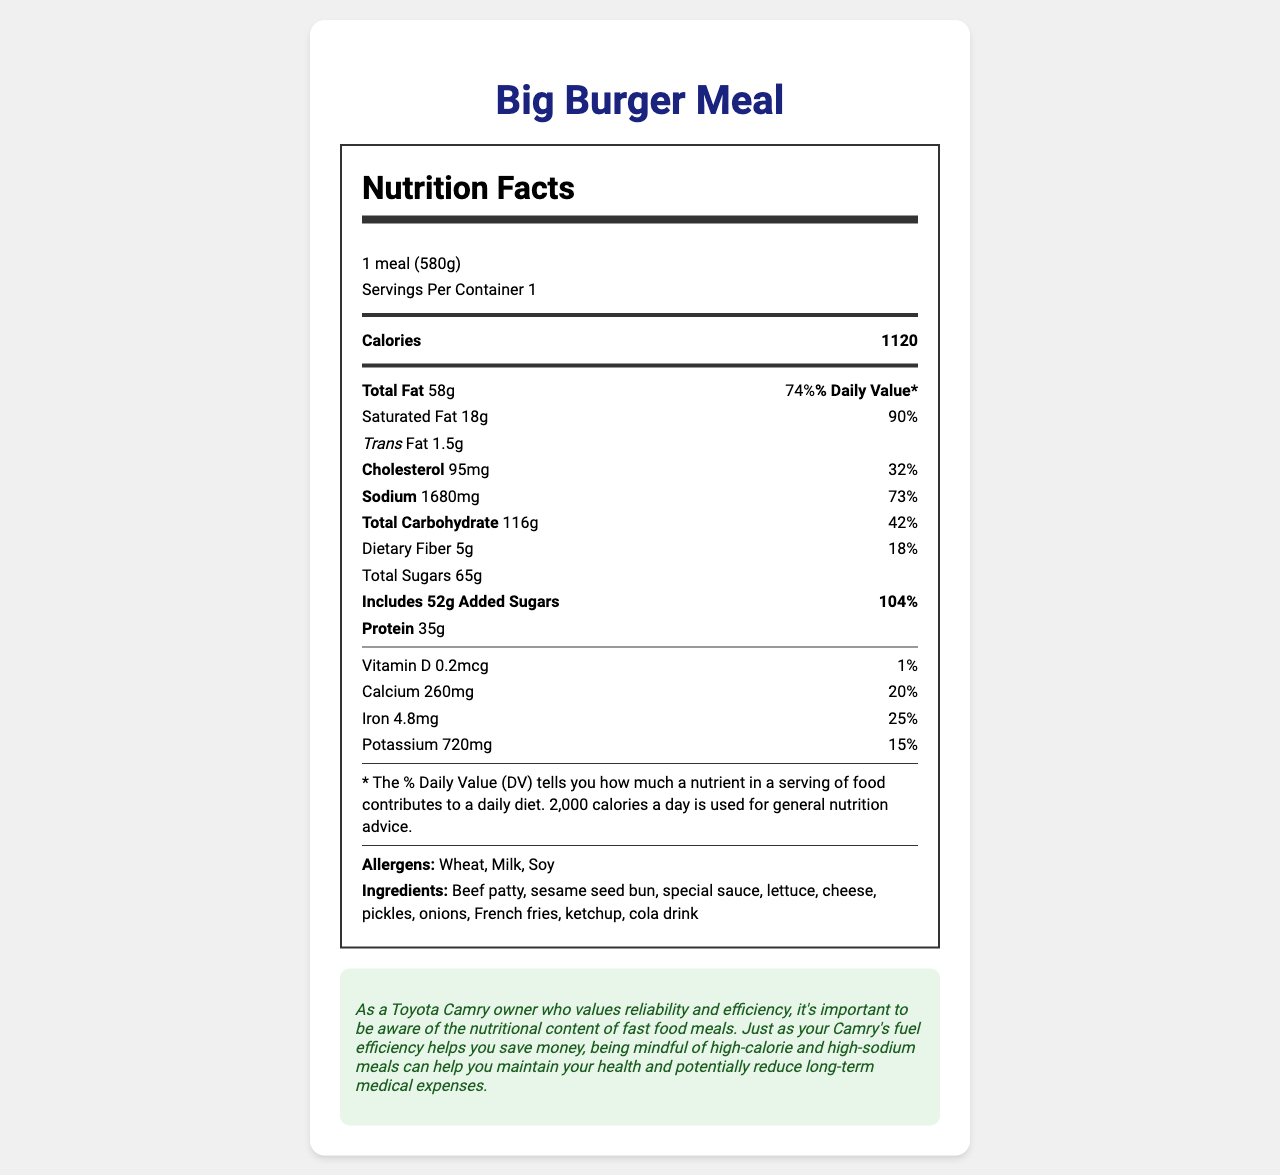what is the serving size of the Big Burger Meal? The serving size is explicitly stated as "1 meal (580g)".
Answer: 1 meal (580g) how many calories does the Big Burger Meal contain? The number of calories is stated under the "Calories" section of the nutrition label.
Answer: 1120 calories what is the sodium content in the Big Burger Meal? The sodium content is listed as 1680mg on the nutrition label.
Answer: 1680mg how much saturated fat is in this meal? The saturated fat content is listed as 18g on the nutrition label.
Answer: 18g what allergens are present in the Big Burger Meal? The allergens are listed towards the end of the nutrition label.
Answer: Wheat, Milk, Soy what is the percentage of daily value for cholesterol in the Big Burger Meal? A. 20% B. 32% C. 45% D. 50% The daily value for cholesterol is shown as 32% on the nutrition label.
Answer: B. 32% which of the following nutrients has the highest daily value percentage? A. Saturated Fat B. Sodium C. Added Sugars The daily value percentages for each are: Saturated Fat 90%, Sodium 73%, and Added Sugars 104%. Added Sugars have the highest percentage.
Answer: C. Added Sugars does the Big Burger Meal contain any Vitamin D? The nutrition label indicates that the meal contains 0.2mcg of Vitamin D.
Answer: Yes which nutrient has a total amount of 720mg in the meal? The nutrition label lists Potassium as having an amount of 720mg.
Answer: Potassium summarize the key nutritional information of the Big Burger Meal. This summary captures the major nutritional elements such as calorie content, major macronutrients, and allergens to provide a comprehensive overview of the meal's nutritional profile.
Answer: The Big Burger Meal has a serving size of 1 meal (580g) and contains 1120 calories. It has significant amounts of fat, sodium, and carbohydrates, with 58g of total fat (74% DV), 1680mg of sodium (73% DV), and 116g of total carbohydrates (42% DV). It also includes significant added sugars at 52g (104% DV). Allergens include Wheat, Milk, and Soy. how much iron does the Big Burger Meal contain? The iron content is listed as 4.8mg on the nutrition label.
Answer: 4.8mg what is the main protein source in the Big Burger Meal? The ingredient list includes Beef patty, which is a common primary protein source in burgers.
Answer: Beef patty how can consuming such a meal regularly impact your long-term health? The document provides nutritional information but does not give details on health impacts or long-term consequences.
Answer: Not enough information 